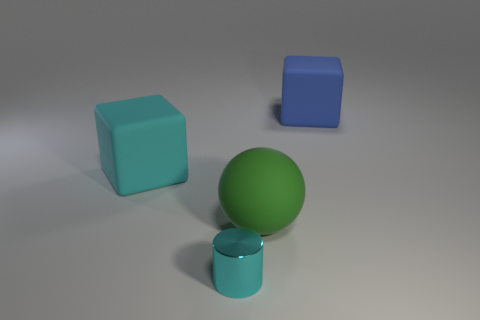There is a cyan matte block to the left of the cyan shiny object; is its size the same as the small metal cylinder?
Give a very brief answer. No. What is the size of the thing that is both on the right side of the large cyan matte object and to the left of the large green matte object?
Ensure brevity in your answer.  Small. There is a thing that is behind the small cylinder and to the left of the ball; what is its shape?
Offer a very short reply. Cube. How many balls are either big gray metallic objects or tiny metal objects?
Provide a short and direct response. 0. Are there fewer tiny cylinders right of the big blue rubber thing than cubes?
Your response must be concise. Yes. What color is the rubber thing that is both behind the large green ball and left of the big blue block?
Offer a terse response. Cyan. What number of other things are there of the same shape as the cyan shiny object?
Keep it short and to the point. 0. Are there fewer shiny cylinders behind the big cyan matte object than objects on the left side of the blue object?
Make the answer very short. Yes. Is the blue block made of the same material as the large block that is on the left side of the big blue cube?
Make the answer very short. Yes. Is there anything else that has the same material as the big cyan block?
Your answer should be compact. Yes. 